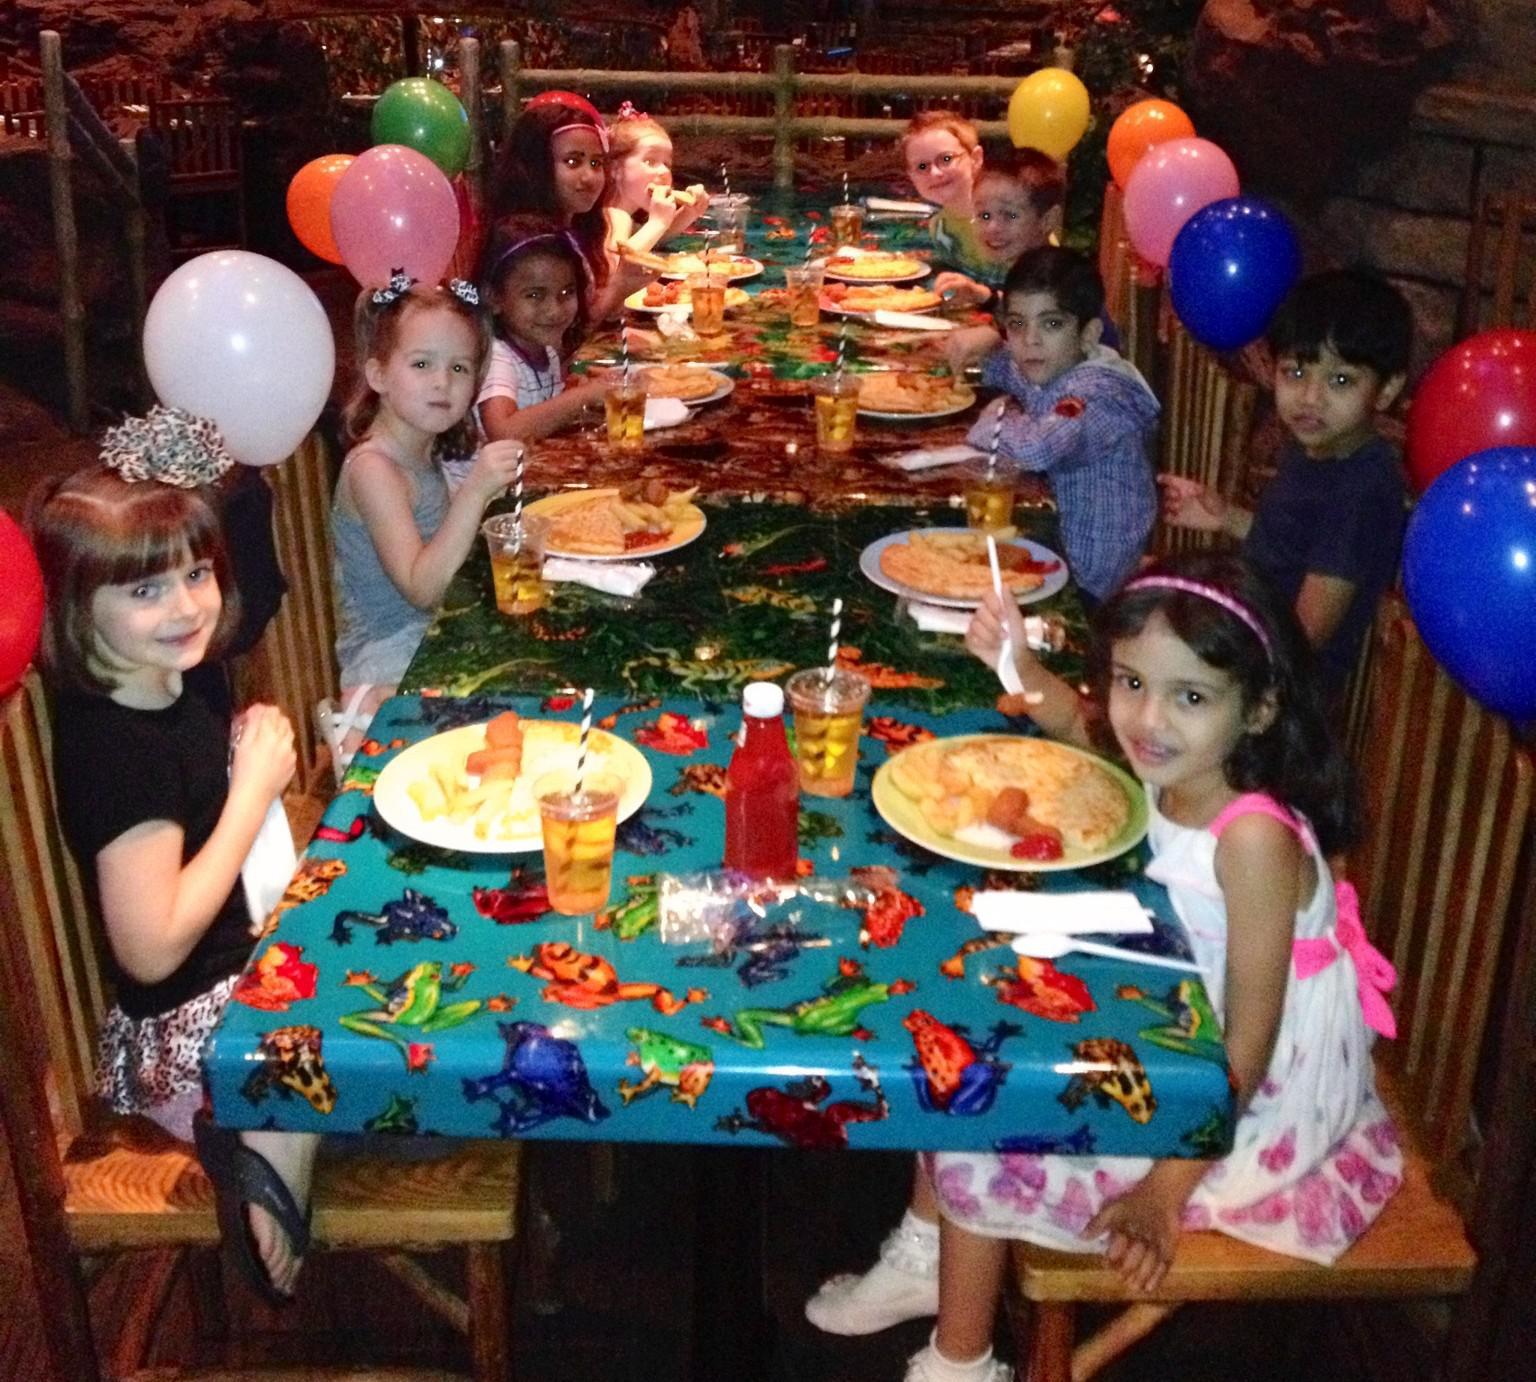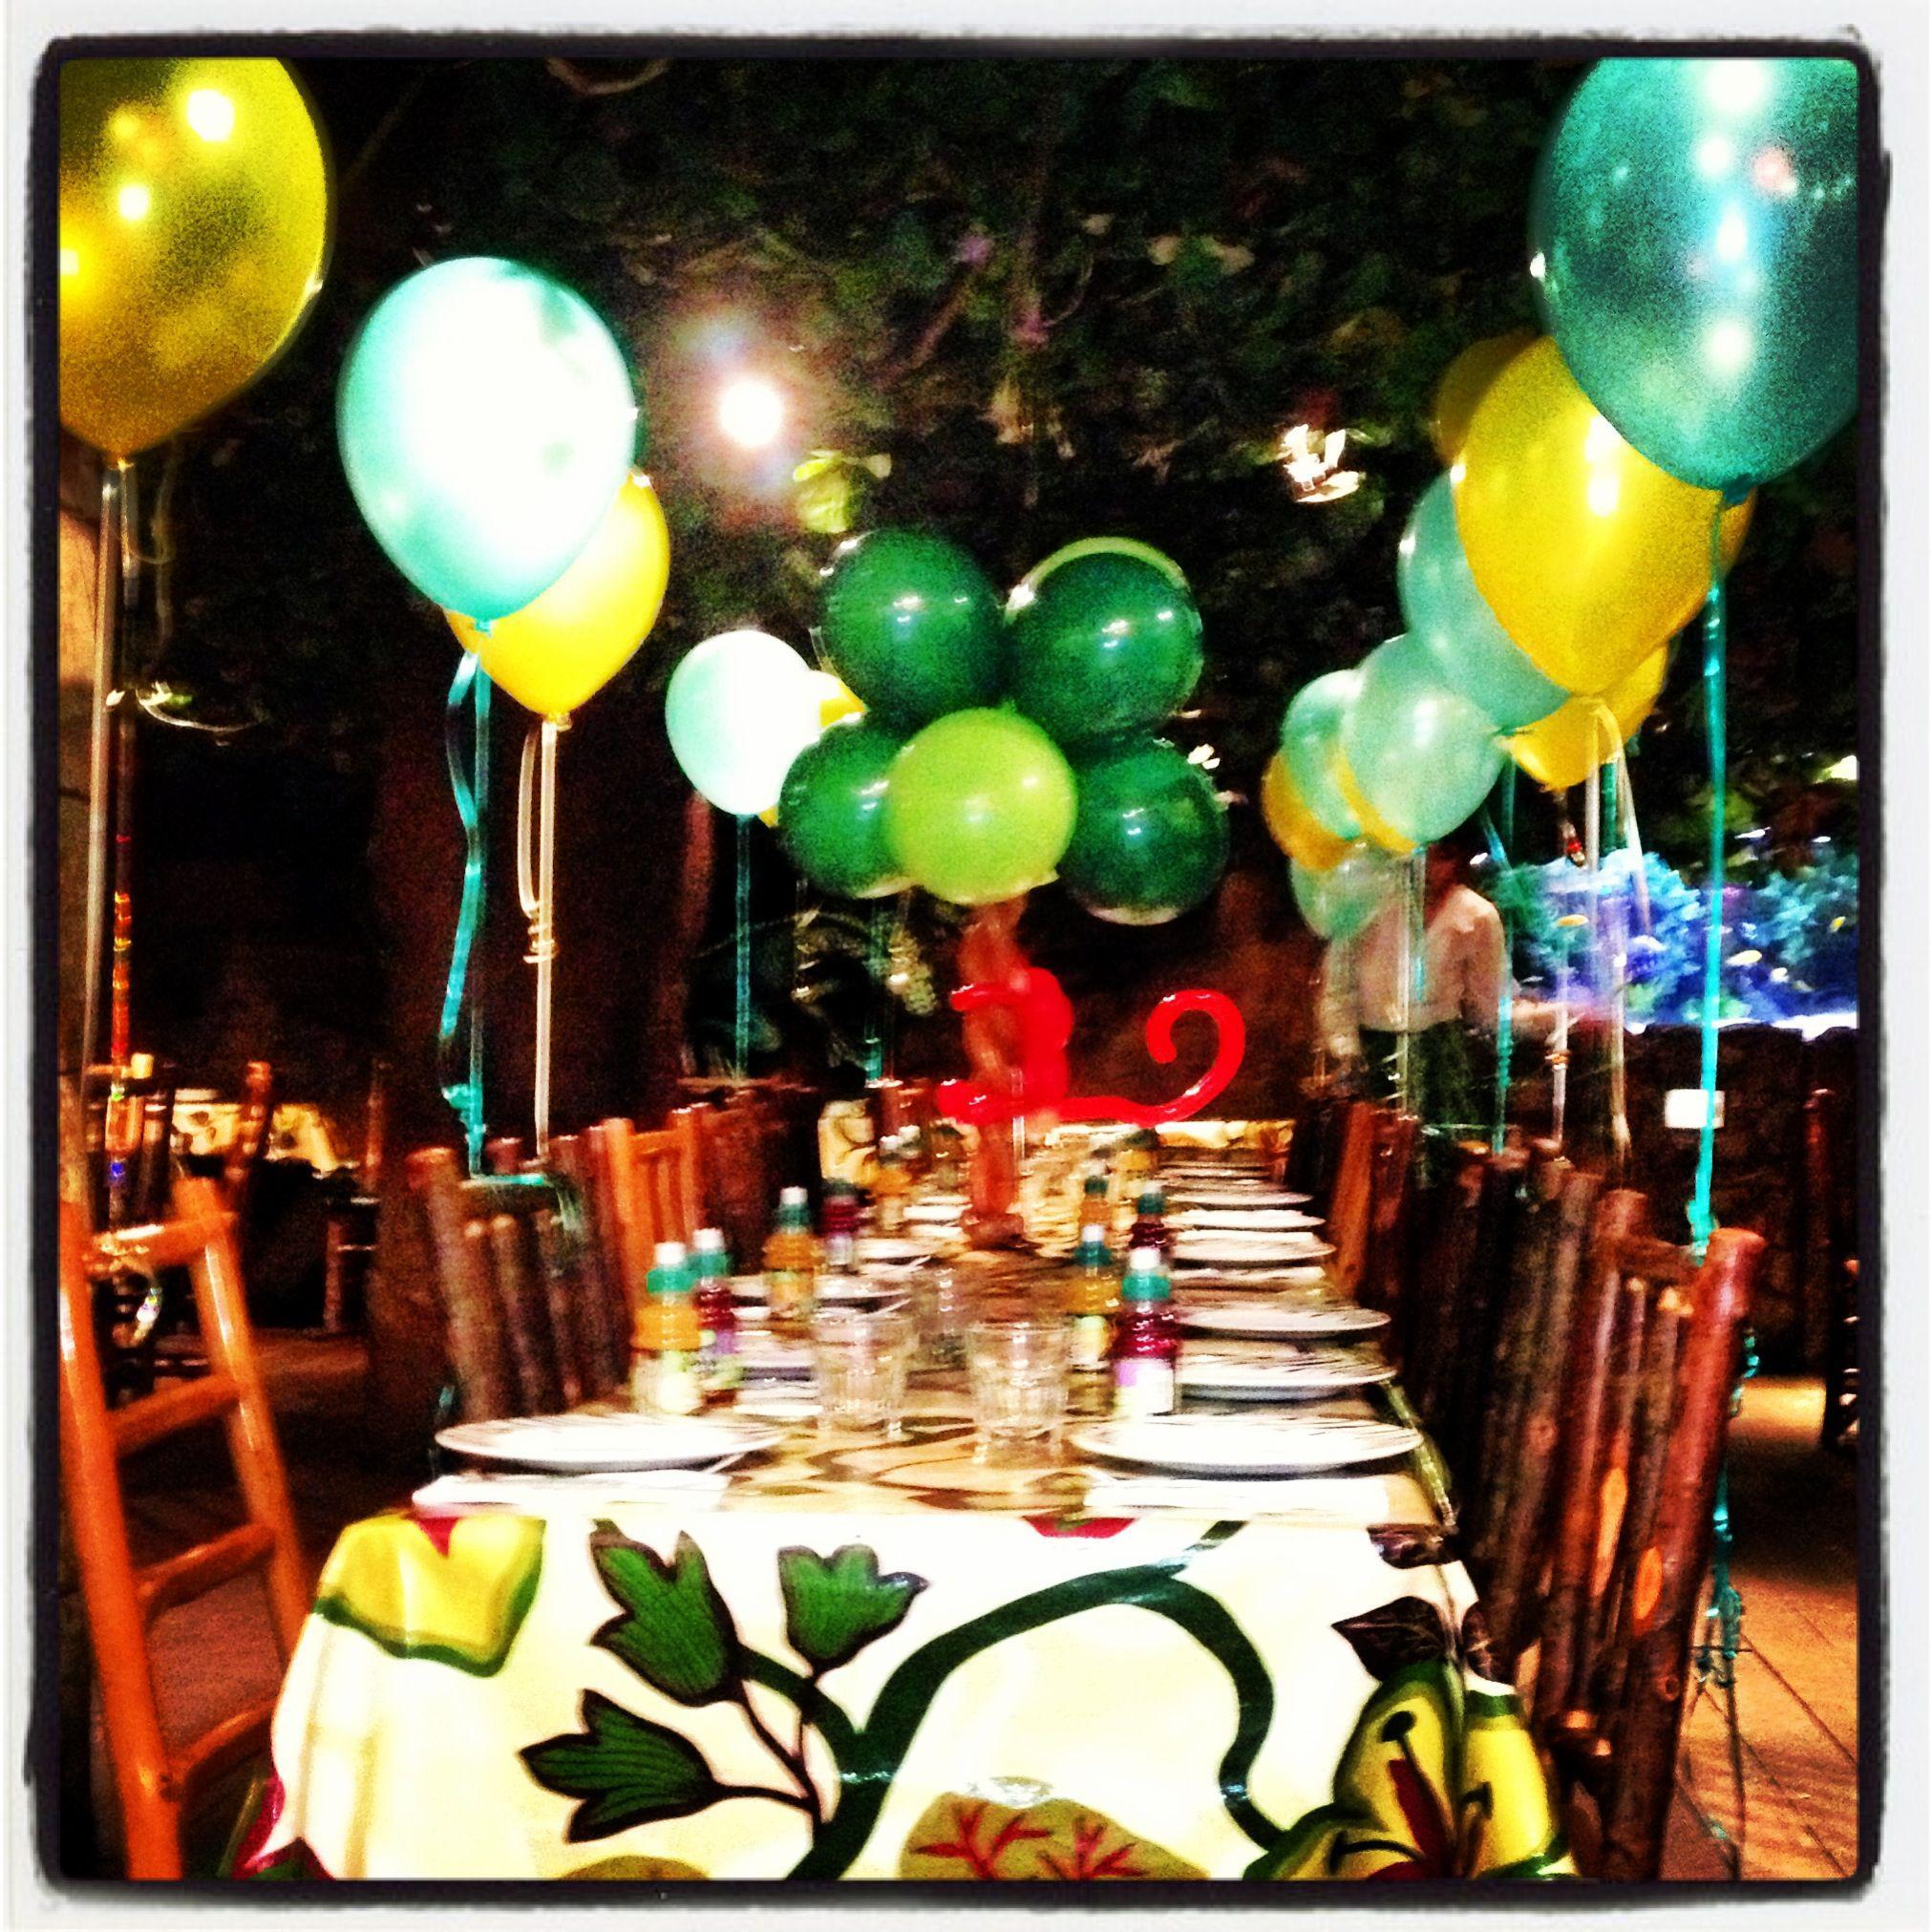The first image is the image on the left, the second image is the image on the right. Evaluate the accuracy of this statement regarding the images: "The right image includes a balloon animal face with small round ears and white balloon eyeballs.". Is it true? Answer yes or no. No. The first image is the image on the left, the second image is the image on the right. Assess this claim about the two images: "Exactly one image contains a balloon animal with eyes.". Correct or not? Answer yes or no. No. 